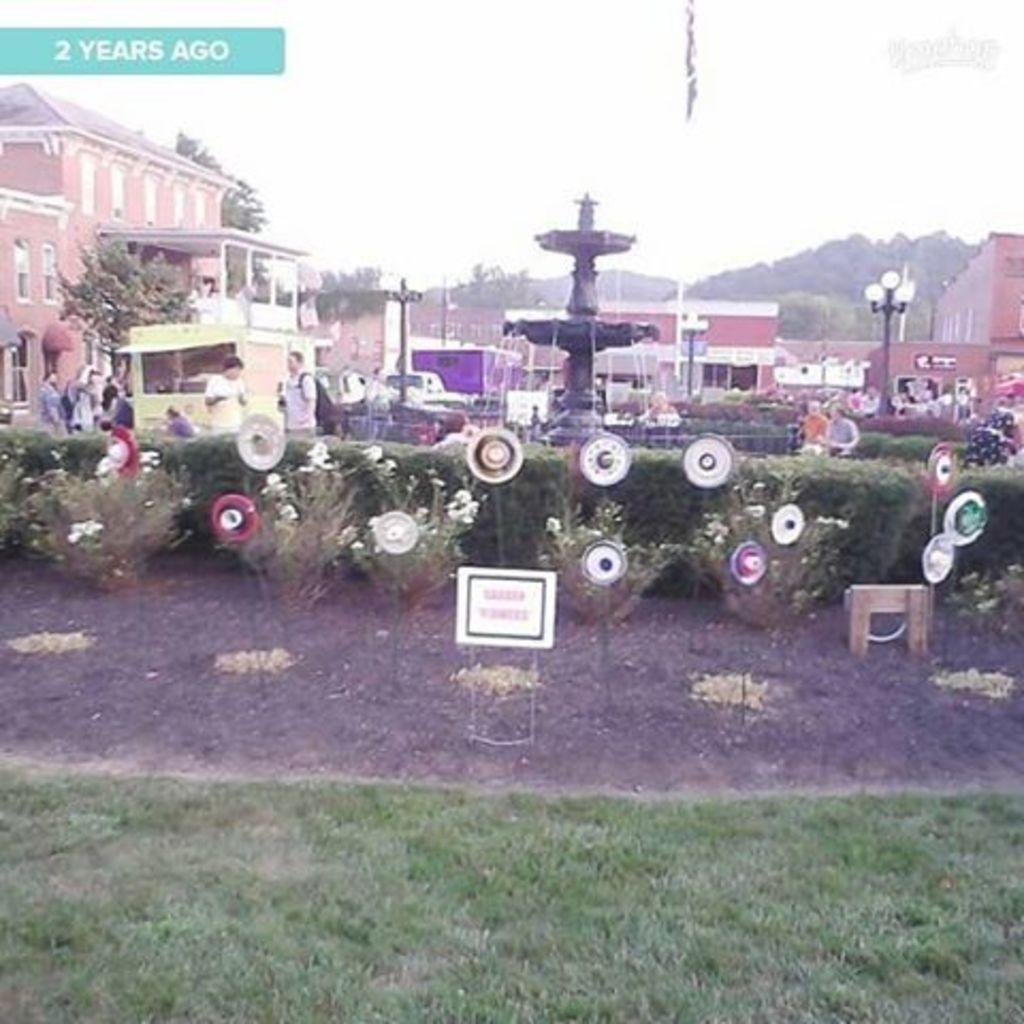What is the main feature in the image? There is a fountain in the image. What else can be seen in the image besides the fountain? There are plants, people walking, buildings, and trees in the background of the image. What is the condition of the sky in the image? The sky is clear in the image. Can you see any nails sticking out of the fountain in the image? There are no nails visible in the image, as the focus is on the fountain and its surroundings. Is there a coastline visible in the image? There is no coastline present in the image; it features a fountain, plants, people walking, buildings, and trees in the background. 